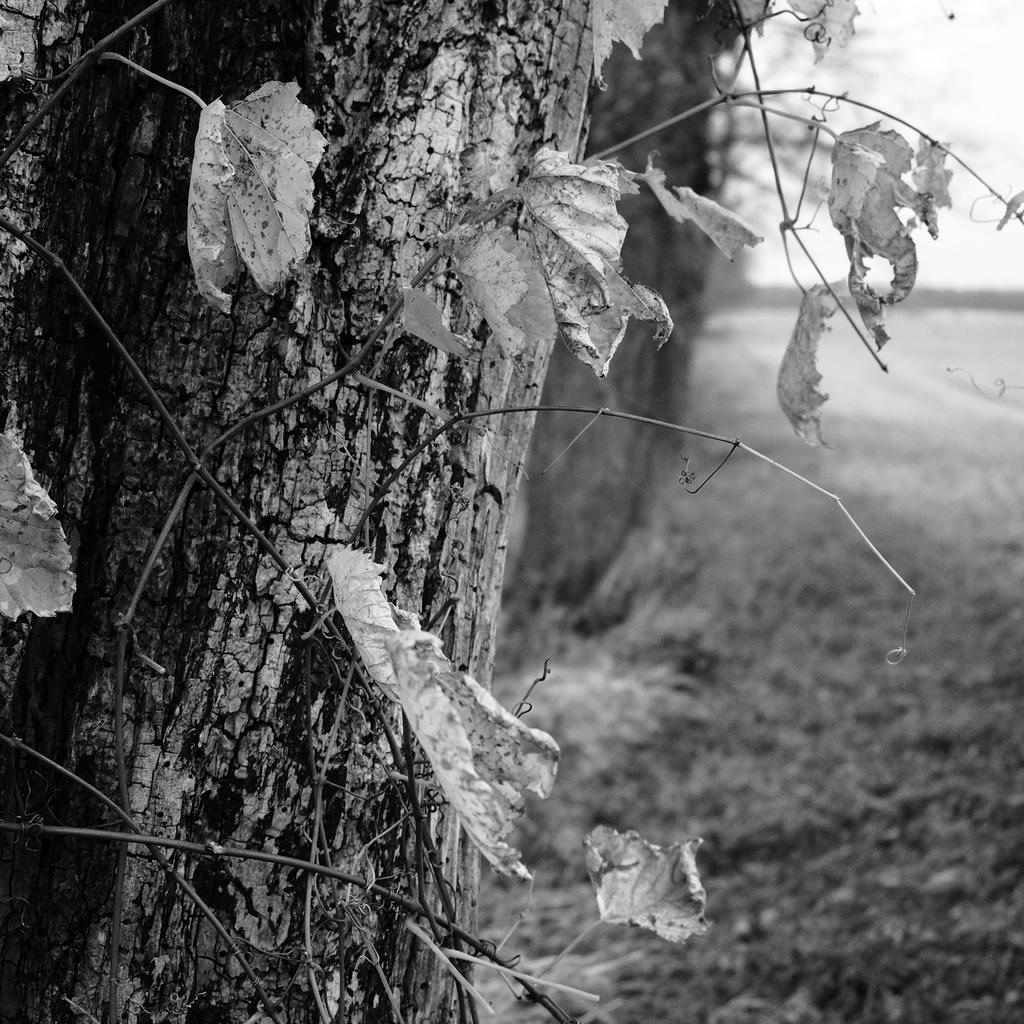What is the color scheme of the image? The image is black and white. What can be seen on the left side of the image? There are dry leaves on the left side of the image. What is the main object in the image? There is a tree trunk in the image. How would you describe the background of the image? The background of the image is blurred. What type of humor is being displayed by the channel in the image? There is no channel or humor present in the image; it is a black and white image featuring dry leaves and a tree trunk with a blurred background. 